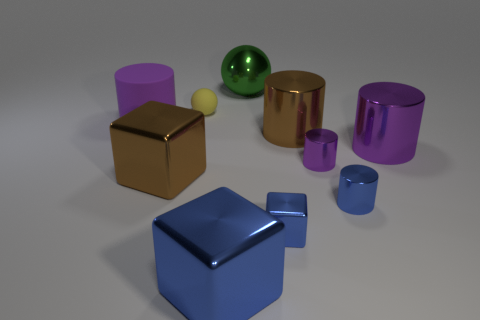There is a purple thing that is in front of the big purple object that is right of the big green metal object; what size is it?
Provide a succinct answer. Small. Are there an equal number of small yellow objects in front of the big rubber thing and brown matte cubes?
Your response must be concise. Yes. How many other things are there of the same color as the tiny metallic block?
Your response must be concise. 2. Are there fewer small blue cylinders that are in front of the small shiny block than tiny purple metal cylinders?
Give a very brief answer. Yes. Is there a shiny cylinder of the same size as the yellow matte sphere?
Offer a terse response. Yes. There is a tiny shiny cube; is it the same color as the big shiny object left of the yellow ball?
Provide a succinct answer. No. There is a shiny thing behind the big matte thing; how many small things are right of it?
Your response must be concise. 3. There is a ball in front of the green metallic thing that is behind the small purple metal cylinder; what color is it?
Provide a succinct answer. Yellow. There is a object that is left of the large blue cube and in front of the big rubber cylinder; what is it made of?
Your answer should be very brief. Metal. Is there a brown metal object that has the same shape as the large blue object?
Your answer should be compact. Yes. 